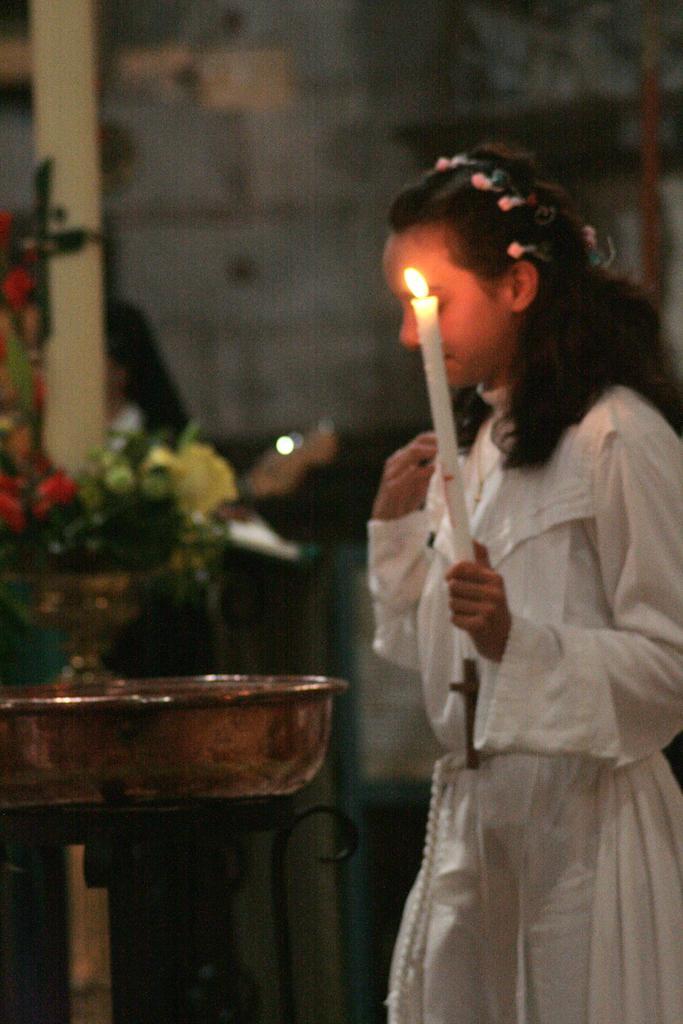How would you summarize this image in a sentence or two? In this image, we can see a person wearing a band, a cross and holding a candle which is lighted. In the background, there are flower vases and we can see another person, a stand and there is a wall. 